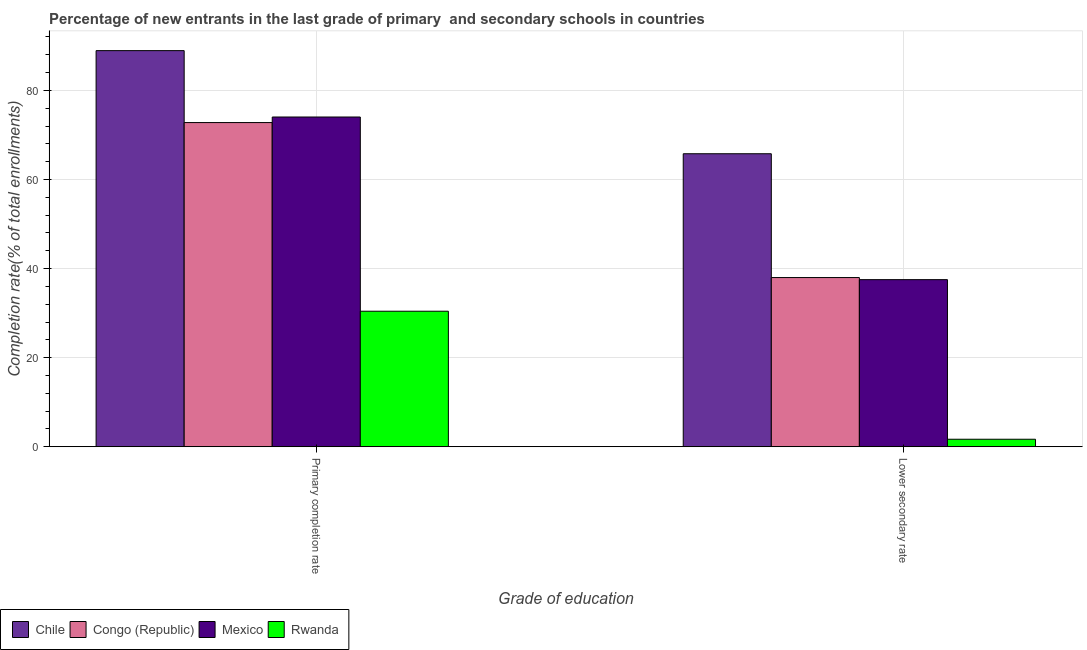How many different coloured bars are there?
Ensure brevity in your answer.  4. How many groups of bars are there?
Provide a short and direct response. 2. Are the number of bars per tick equal to the number of legend labels?
Give a very brief answer. Yes. How many bars are there on the 1st tick from the left?
Provide a succinct answer. 4. How many bars are there on the 1st tick from the right?
Offer a very short reply. 4. What is the label of the 2nd group of bars from the left?
Make the answer very short. Lower secondary rate. What is the completion rate in secondary schools in Mexico?
Ensure brevity in your answer.  37.51. Across all countries, what is the maximum completion rate in secondary schools?
Ensure brevity in your answer.  65.78. Across all countries, what is the minimum completion rate in primary schools?
Give a very brief answer. 30.42. In which country was the completion rate in primary schools minimum?
Ensure brevity in your answer.  Rwanda. What is the total completion rate in primary schools in the graph?
Offer a very short reply. 266.18. What is the difference between the completion rate in secondary schools in Chile and that in Congo (Republic)?
Offer a very short reply. 27.8. What is the difference between the completion rate in secondary schools in Mexico and the completion rate in primary schools in Congo (Republic)?
Offer a very short reply. -35.27. What is the average completion rate in primary schools per country?
Provide a succinct answer. 66.54. What is the difference between the completion rate in primary schools and completion rate in secondary schools in Chile?
Your answer should be very brief. 23.15. What is the ratio of the completion rate in secondary schools in Mexico to that in Congo (Republic)?
Provide a succinct answer. 0.99. Is the completion rate in primary schools in Congo (Republic) less than that in Mexico?
Offer a terse response. Yes. In how many countries, is the completion rate in primary schools greater than the average completion rate in primary schools taken over all countries?
Keep it short and to the point. 3. What does the 2nd bar from the left in Lower secondary rate represents?
Provide a short and direct response. Congo (Republic). What does the 4th bar from the right in Lower secondary rate represents?
Give a very brief answer. Chile. How many bars are there?
Your answer should be very brief. 8. How many countries are there in the graph?
Give a very brief answer. 4. Are the values on the major ticks of Y-axis written in scientific E-notation?
Offer a terse response. No. How many legend labels are there?
Your response must be concise. 4. What is the title of the graph?
Your response must be concise. Percentage of new entrants in the last grade of primary  and secondary schools in countries. Does "Fiji" appear as one of the legend labels in the graph?
Ensure brevity in your answer.  No. What is the label or title of the X-axis?
Ensure brevity in your answer.  Grade of education. What is the label or title of the Y-axis?
Offer a very short reply. Completion rate(% of total enrollments). What is the Completion rate(% of total enrollments) in Chile in Primary completion rate?
Give a very brief answer. 88.94. What is the Completion rate(% of total enrollments) in Congo (Republic) in Primary completion rate?
Ensure brevity in your answer.  72.78. What is the Completion rate(% of total enrollments) of Mexico in Primary completion rate?
Your answer should be very brief. 74.03. What is the Completion rate(% of total enrollments) of Rwanda in Primary completion rate?
Offer a very short reply. 30.42. What is the Completion rate(% of total enrollments) in Chile in Lower secondary rate?
Offer a terse response. 65.78. What is the Completion rate(% of total enrollments) in Congo (Republic) in Lower secondary rate?
Provide a short and direct response. 37.99. What is the Completion rate(% of total enrollments) of Mexico in Lower secondary rate?
Your answer should be very brief. 37.51. What is the Completion rate(% of total enrollments) of Rwanda in Lower secondary rate?
Keep it short and to the point. 1.68. Across all Grade of education, what is the maximum Completion rate(% of total enrollments) of Chile?
Your answer should be very brief. 88.94. Across all Grade of education, what is the maximum Completion rate(% of total enrollments) of Congo (Republic)?
Make the answer very short. 72.78. Across all Grade of education, what is the maximum Completion rate(% of total enrollments) in Mexico?
Keep it short and to the point. 74.03. Across all Grade of education, what is the maximum Completion rate(% of total enrollments) in Rwanda?
Make the answer very short. 30.42. Across all Grade of education, what is the minimum Completion rate(% of total enrollments) in Chile?
Give a very brief answer. 65.78. Across all Grade of education, what is the minimum Completion rate(% of total enrollments) of Congo (Republic)?
Provide a succinct answer. 37.99. Across all Grade of education, what is the minimum Completion rate(% of total enrollments) in Mexico?
Offer a very short reply. 37.51. Across all Grade of education, what is the minimum Completion rate(% of total enrollments) of Rwanda?
Your response must be concise. 1.68. What is the total Completion rate(% of total enrollments) in Chile in the graph?
Keep it short and to the point. 154.72. What is the total Completion rate(% of total enrollments) in Congo (Republic) in the graph?
Your answer should be compact. 110.77. What is the total Completion rate(% of total enrollments) of Mexico in the graph?
Keep it short and to the point. 111.55. What is the total Completion rate(% of total enrollments) of Rwanda in the graph?
Make the answer very short. 32.1. What is the difference between the Completion rate(% of total enrollments) of Chile in Primary completion rate and that in Lower secondary rate?
Provide a short and direct response. 23.15. What is the difference between the Completion rate(% of total enrollments) of Congo (Republic) in Primary completion rate and that in Lower secondary rate?
Give a very brief answer. 34.8. What is the difference between the Completion rate(% of total enrollments) of Mexico in Primary completion rate and that in Lower secondary rate?
Your answer should be compact. 36.52. What is the difference between the Completion rate(% of total enrollments) in Rwanda in Primary completion rate and that in Lower secondary rate?
Provide a succinct answer. 28.75. What is the difference between the Completion rate(% of total enrollments) in Chile in Primary completion rate and the Completion rate(% of total enrollments) in Congo (Republic) in Lower secondary rate?
Your answer should be compact. 50.95. What is the difference between the Completion rate(% of total enrollments) of Chile in Primary completion rate and the Completion rate(% of total enrollments) of Mexico in Lower secondary rate?
Ensure brevity in your answer.  51.42. What is the difference between the Completion rate(% of total enrollments) of Chile in Primary completion rate and the Completion rate(% of total enrollments) of Rwanda in Lower secondary rate?
Your answer should be very brief. 87.26. What is the difference between the Completion rate(% of total enrollments) in Congo (Republic) in Primary completion rate and the Completion rate(% of total enrollments) in Mexico in Lower secondary rate?
Offer a terse response. 35.27. What is the difference between the Completion rate(% of total enrollments) of Congo (Republic) in Primary completion rate and the Completion rate(% of total enrollments) of Rwanda in Lower secondary rate?
Make the answer very short. 71.1. What is the difference between the Completion rate(% of total enrollments) in Mexico in Primary completion rate and the Completion rate(% of total enrollments) in Rwanda in Lower secondary rate?
Make the answer very short. 72.35. What is the average Completion rate(% of total enrollments) in Chile per Grade of education?
Provide a succinct answer. 77.36. What is the average Completion rate(% of total enrollments) of Congo (Republic) per Grade of education?
Your response must be concise. 55.38. What is the average Completion rate(% of total enrollments) in Mexico per Grade of education?
Keep it short and to the point. 55.77. What is the average Completion rate(% of total enrollments) of Rwanda per Grade of education?
Your response must be concise. 16.05. What is the difference between the Completion rate(% of total enrollments) of Chile and Completion rate(% of total enrollments) of Congo (Republic) in Primary completion rate?
Ensure brevity in your answer.  16.15. What is the difference between the Completion rate(% of total enrollments) of Chile and Completion rate(% of total enrollments) of Mexico in Primary completion rate?
Keep it short and to the point. 14.91. What is the difference between the Completion rate(% of total enrollments) of Chile and Completion rate(% of total enrollments) of Rwanda in Primary completion rate?
Your response must be concise. 58.51. What is the difference between the Completion rate(% of total enrollments) of Congo (Republic) and Completion rate(% of total enrollments) of Mexico in Primary completion rate?
Make the answer very short. -1.25. What is the difference between the Completion rate(% of total enrollments) in Congo (Republic) and Completion rate(% of total enrollments) in Rwanda in Primary completion rate?
Give a very brief answer. 42.36. What is the difference between the Completion rate(% of total enrollments) of Mexico and Completion rate(% of total enrollments) of Rwanda in Primary completion rate?
Ensure brevity in your answer.  43.61. What is the difference between the Completion rate(% of total enrollments) in Chile and Completion rate(% of total enrollments) in Congo (Republic) in Lower secondary rate?
Make the answer very short. 27.8. What is the difference between the Completion rate(% of total enrollments) in Chile and Completion rate(% of total enrollments) in Mexico in Lower secondary rate?
Your answer should be compact. 28.27. What is the difference between the Completion rate(% of total enrollments) in Chile and Completion rate(% of total enrollments) in Rwanda in Lower secondary rate?
Provide a succinct answer. 64.11. What is the difference between the Completion rate(% of total enrollments) of Congo (Republic) and Completion rate(% of total enrollments) of Mexico in Lower secondary rate?
Your answer should be very brief. 0.47. What is the difference between the Completion rate(% of total enrollments) in Congo (Republic) and Completion rate(% of total enrollments) in Rwanda in Lower secondary rate?
Provide a short and direct response. 36.31. What is the difference between the Completion rate(% of total enrollments) in Mexico and Completion rate(% of total enrollments) in Rwanda in Lower secondary rate?
Offer a terse response. 35.84. What is the ratio of the Completion rate(% of total enrollments) of Chile in Primary completion rate to that in Lower secondary rate?
Give a very brief answer. 1.35. What is the ratio of the Completion rate(% of total enrollments) in Congo (Republic) in Primary completion rate to that in Lower secondary rate?
Provide a short and direct response. 1.92. What is the ratio of the Completion rate(% of total enrollments) in Mexico in Primary completion rate to that in Lower secondary rate?
Provide a succinct answer. 1.97. What is the ratio of the Completion rate(% of total enrollments) in Rwanda in Primary completion rate to that in Lower secondary rate?
Keep it short and to the point. 18.12. What is the difference between the highest and the second highest Completion rate(% of total enrollments) in Chile?
Ensure brevity in your answer.  23.15. What is the difference between the highest and the second highest Completion rate(% of total enrollments) in Congo (Republic)?
Your answer should be compact. 34.8. What is the difference between the highest and the second highest Completion rate(% of total enrollments) of Mexico?
Provide a short and direct response. 36.52. What is the difference between the highest and the second highest Completion rate(% of total enrollments) of Rwanda?
Your answer should be very brief. 28.75. What is the difference between the highest and the lowest Completion rate(% of total enrollments) in Chile?
Keep it short and to the point. 23.15. What is the difference between the highest and the lowest Completion rate(% of total enrollments) in Congo (Republic)?
Give a very brief answer. 34.8. What is the difference between the highest and the lowest Completion rate(% of total enrollments) in Mexico?
Keep it short and to the point. 36.52. What is the difference between the highest and the lowest Completion rate(% of total enrollments) in Rwanda?
Your answer should be very brief. 28.75. 